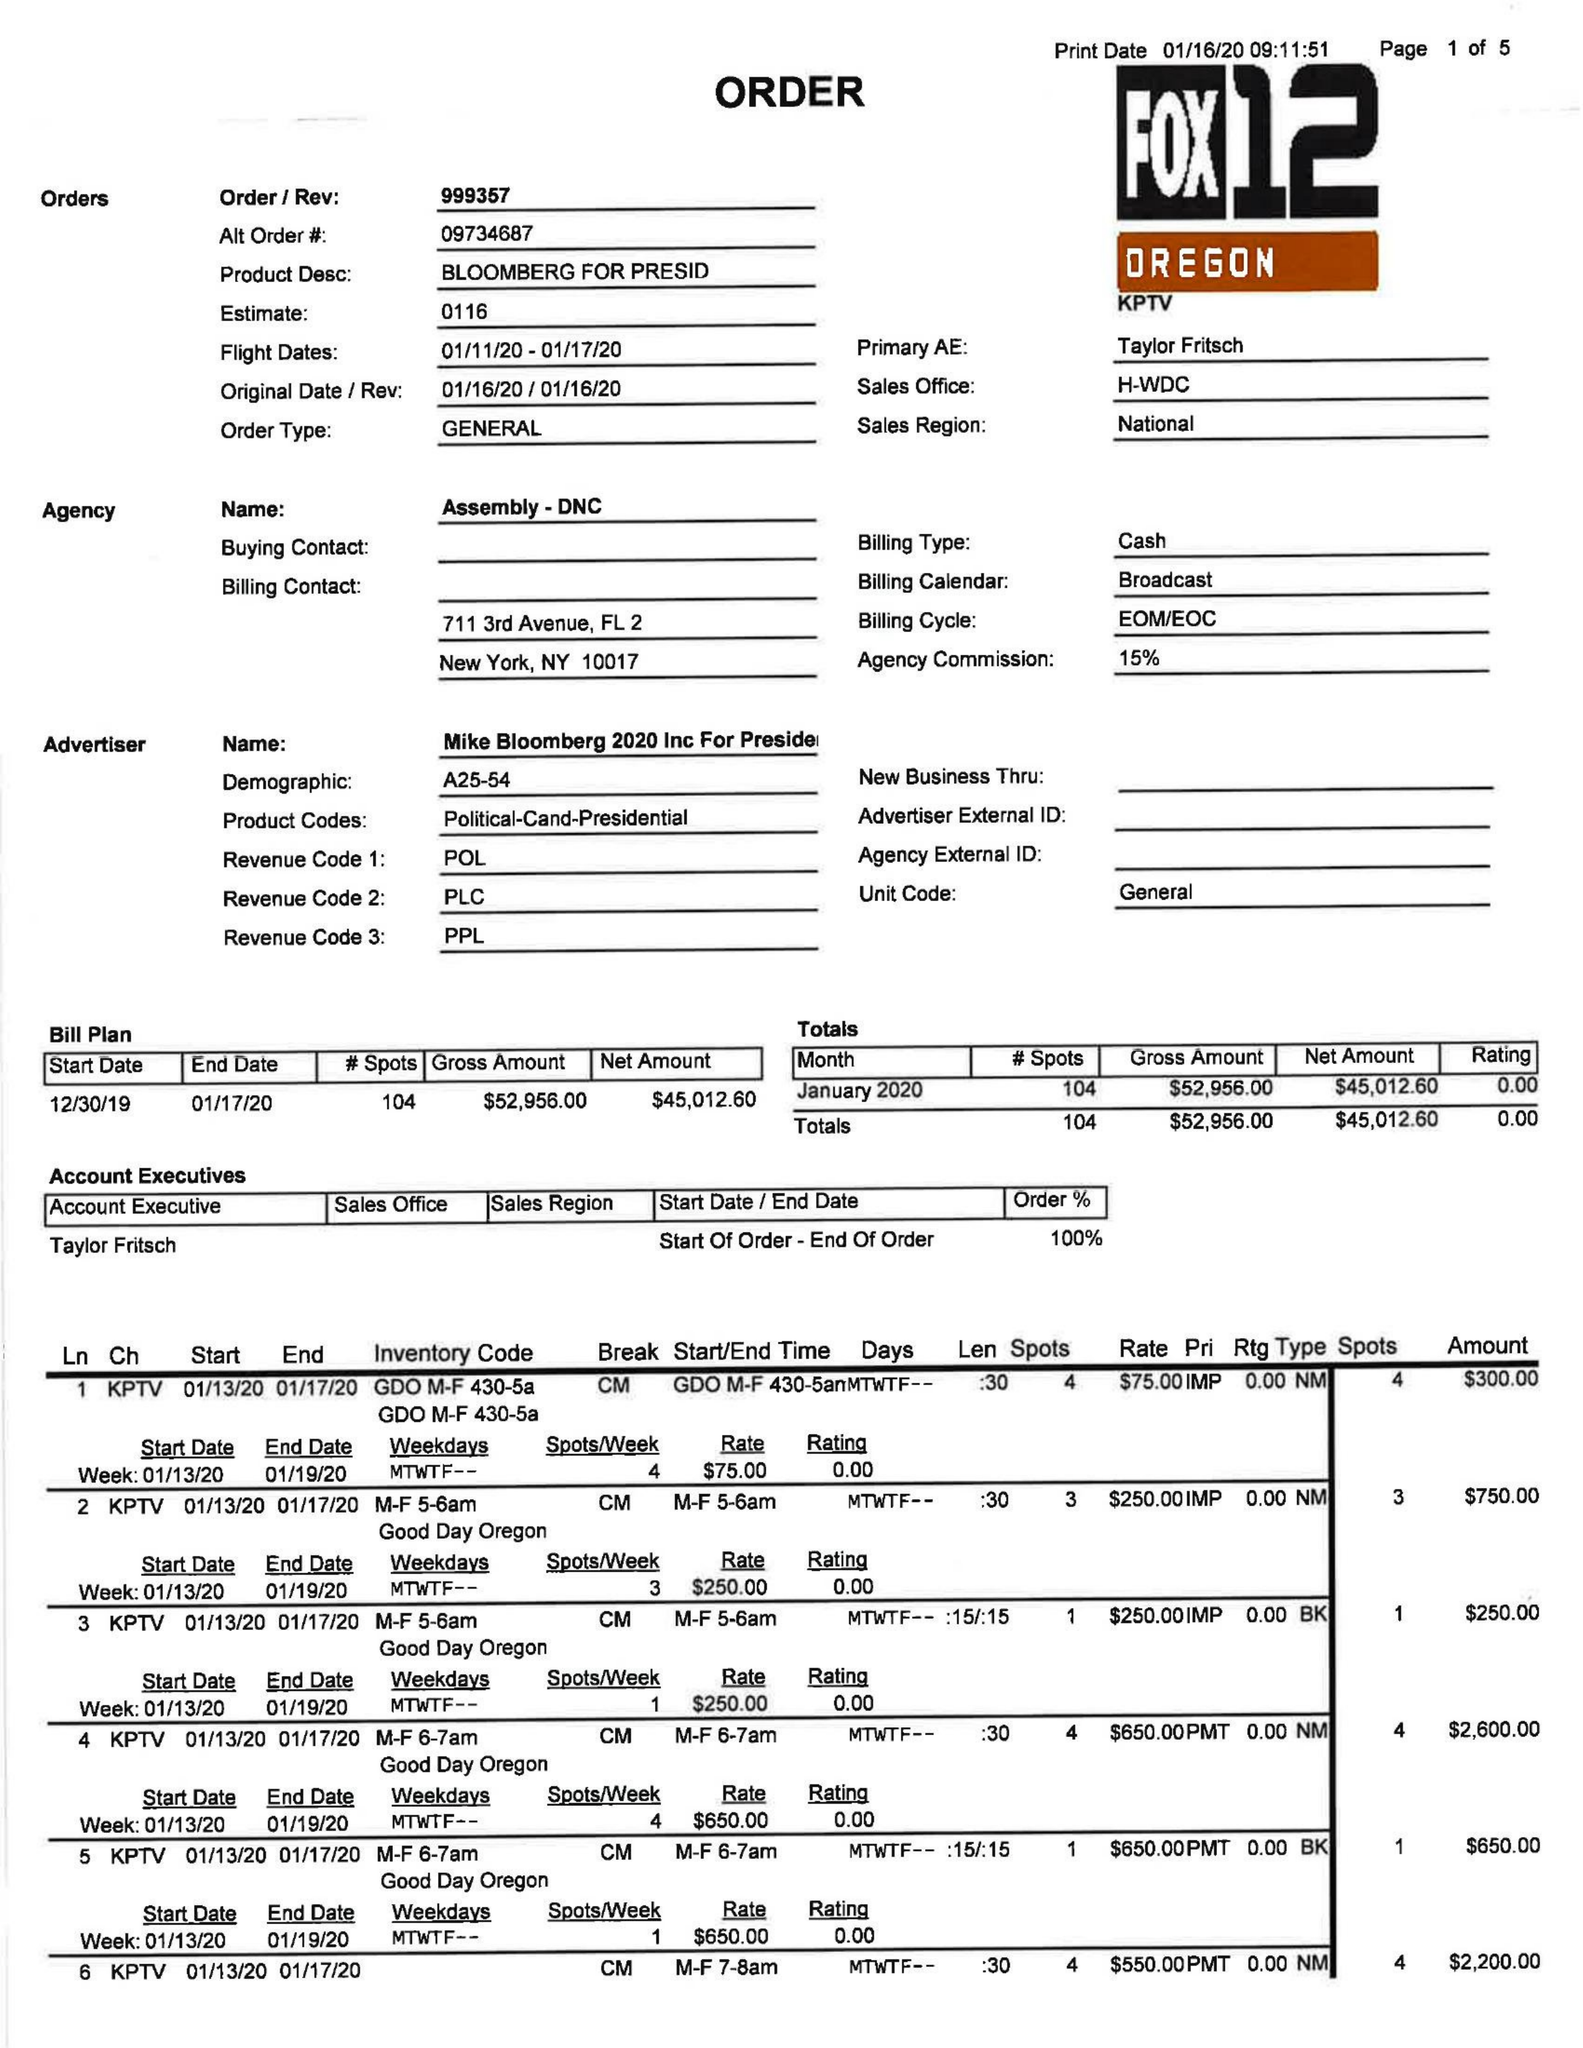What is the value for the advertiser?
Answer the question using a single word or phrase. MIKE BLOOMBERG 2020 INC FOR PRESIDENT 